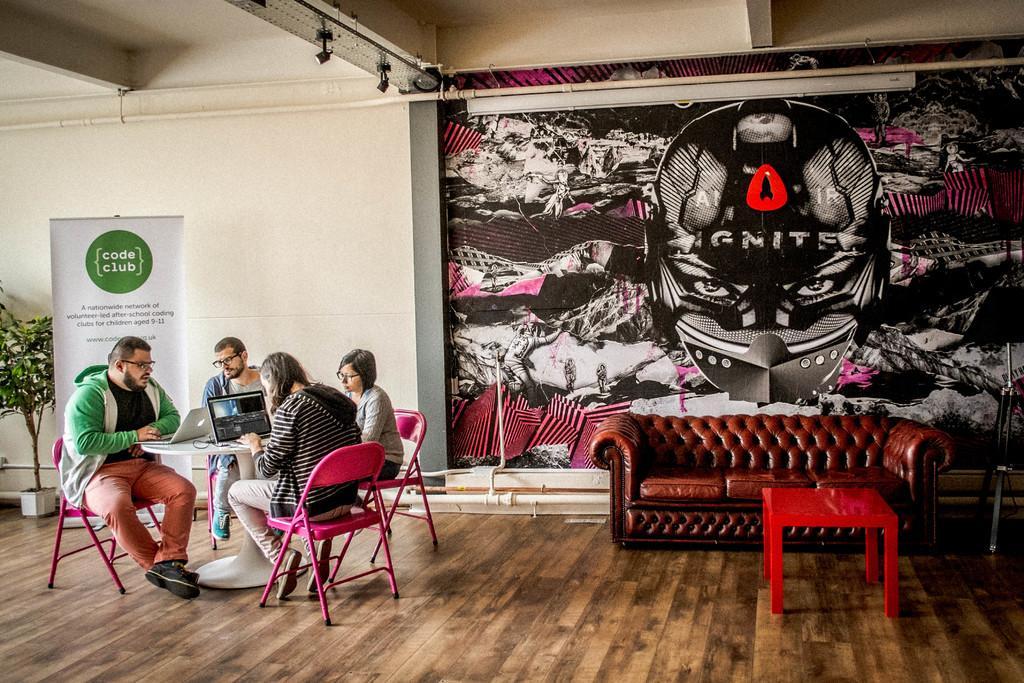Please provide a concise description of this image. In a picture we can find four people are sitting on the chairs, Two are women and two are men, the four people are watching laptop. In the background we can find a painting wall and one hoarding and a plant and we can also find sofa and a small table. And a ceiling we can find a lights. 